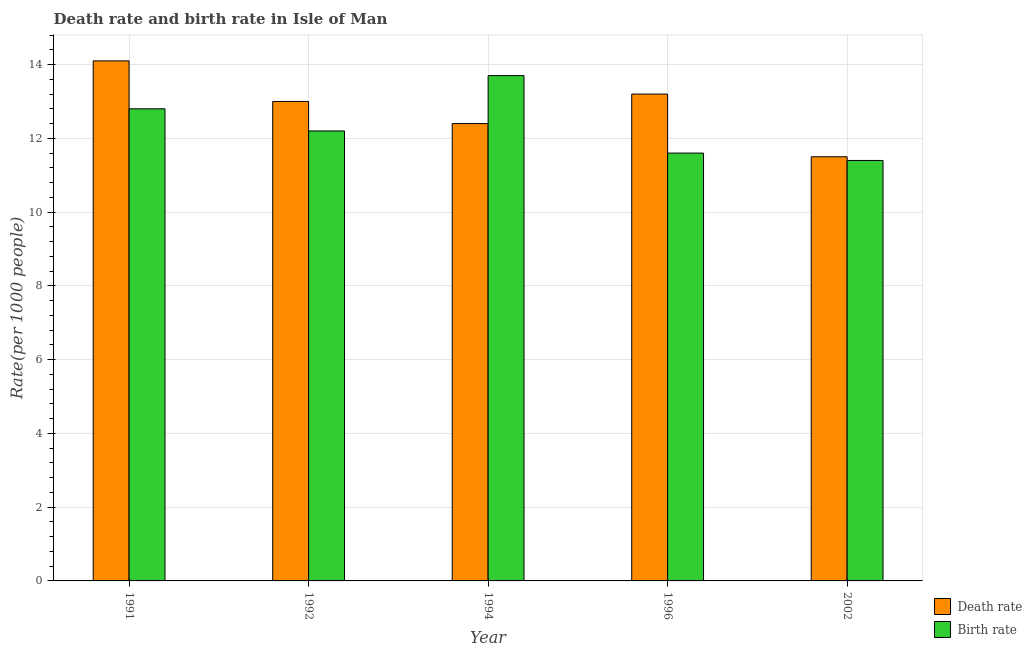How many different coloured bars are there?
Give a very brief answer. 2. How many groups of bars are there?
Your answer should be compact. 5. Are the number of bars per tick equal to the number of legend labels?
Your answer should be compact. Yes. How many bars are there on the 5th tick from the left?
Your response must be concise. 2. How many bars are there on the 3rd tick from the right?
Ensure brevity in your answer.  2. What is the label of the 5th group of bars from the left?
Keep it short and to the point. 2002. What is the death rate in 1992?
Ensure brevity in your answer.  13. In which year was the death rate maximum?
Provide a succinct answer. 1991. In which year was the birth rate minimum?
Your answer should be compact. 2002. What is the total birth rate in the graph?
Keep it short and to the point. 61.7. What is the difference between the death rate in 1994 and that in 1996?
Provide a succinct answer. -0.8. What is the difference between the death rate in 1992 and the birth rate in 1994?
Provide a succinct answer. 0.6. What is the average death rate per year?
Your answer should be very brief. 12.84. In the year 1994, what is the difference between the birth rate and death rate?
Offer a terse response. 0. In how many years, is the death rate greater than 4?
Your answer should be compact. 5. What is the ratio of the death rate in 1992 to that in 1996?
Make the answer very short. 0.98. What is the difference between the highest and the second highest death rate?
Your answer should be compact. 0.9. What is the difference between the highest and the lowest birth rate?
Keep it short and to the point. 2.3. In how many years, is the death rate greater than the average death rate taken over all years?
Offer a very short reply. 3. Is the sum of the birth rate in 1994 and 1996 greater than the maximum death rate across all years?
Your response must be concise. Yes. What does the 2nd bar from the left in 1991 represents?
Your response must be concise. Birth rate. What does the 1st bar from the right in 1994 represents?
Offer a very short reply. Birth rate. How many years are there in the graph?
Keep it short and to the point. 5. Does the graph contain grids?
Ensure brevity in your answer.  Yes. How many legend labels are there?
Offer a terse response. 2. What is the title of the graph?
Make the answer very short. Death rate and birth rate in Isle of Man. Does "Fertility rate" appear as one of the legend labels in the graph?
Keep it short and to the point. No. What is the label or title of the Y-axis?
Provide a succinct answer. Rate(per 1000 people). What is the Rate(per 1000 people) in Birth rate in 1992?
Your answer should be very brief. 12.2. What is the Rate(per 1000 people) in Birth rate in 1994?
Make the answer very short. 13.7. What is the Rate(per 1000 people) of Death rate in 1996?
Your answer should be very brief. 13.2. What is the Rate(per 1000 people) of Birth rate in 1996?
Offer a terse response. 11.6. What is the Rate(per 1000 people) of Birth rate in 2002?
Your answer should be very brief. 11.4. Across all years, what is the maximum Rate(per 1000 people) in Death rate?
Keep it short and to the point. 14.1. Across all years, what is the minimum Rate(per 1000 people) in Death rate?
Offer a terse response. 11.5. What is the total Rate(per 1000 people) of Death rate in the graph?
Ensure brevity in your answer.  64.2. What is the total Rate(per 1000 people) in Birth rate in the graph?
Keep it short and to the point. 61.7. What is the difference between the Rate(per 1000 people) of Death rate in 1991 and that in 1994?
Your response must be concise. 1.7. What is the difference between the Rate(per 1000 people) of Birth rate in 1991 and that in 1994?
Your answer should be very brief. -0.9. What is the difference between the Rate(per 1000 people) in Death rate in 1991 and that in 1996?
Offer a very short reply. 0.9. What is the difference between the Rate(per 1000 people) of Death rate in 1992 and that in 1994?
Your answer should be compact. 0.6. What is the difference between the Rate(per 1000 people) of Birth rate in 1992 and that in 1994?
Provide a succinct answer. -1.5. What is the difference between the Rate(per 1000 people) in Death rate in 1992 and that in 1996?
Provide a short and direct response. -0.2. What is the difference between the Rate(per 1000 people) of Death rate in 1992 and that in 2002?
Ensure brevity in your answer.  1.5. What is the difference between the Rate(per 1000 people) in Birth rate in 1994 and that in 2002?
Keep it short and to the point. 2.3. What is the difference between the Rate(per 1000 people) of Death rate in 1996 and that in 2002?
Provide a succinct answer. 1.7. What is the difference between the Rate(per 1000 people) in Birth rate in 1996 and that in 2002?
Keep it short and to the point. 0.2. What is the difference between the Rate(per 1000 people) in Death rate in 1991 and the Rate(per 1000 people) in Birth rate in 1992?
Provide a short and direct response. 1.9. What is the difference between the Rate(per 1000 people) of Death rate in 1991 and the Rate(per 1000 people) of Birth rate in 1996?
Give a very brief answer. 2.5. What is the difference between the Rate(per 1000 people) in Death rate in 1991 and the Rate(per 1000 people) in Birth rate in 2002?
Make the answer very short. 2.7. What is the difference between the Rate(per 1000 people) of Death rate in 1992 and the Rate(per 1000 people) of Birth rate in 1994?
Make the answer very short. -0.7. What is the difference between the Rate(per 1000 people) in Death rate in 1992 and the Rate(per 1000 people) in Birth rate in 1996?
Provide a succinct answer. 1.4. What is the difference between the Rate(per 1000 people) in Death rate in 1992 and the Rate(per 1000 people) in Birth rate in 2002?
Your answer should be compact. 1.6. What is the difference between the Rate(per 1000 people) in Death rate in 1994 and the Rate(per 1000 people) in Birth rate in 2002?
Your answer should be compact. 1. What is the difference between the Rate(per 1000 people) in Death rate in 1996 and the Rate(per 1000 people) in Birth rate in 2002?
Keep it short and to the point. 1.8. What is the average Rate(per 1000 people) in Death rate per year?
Keep it short and to the point. 12.84. What is the average Rate(per 1000 people) in Birth rate per year?
Your response must be concise. 12.34. In the year 1991, what is the difference between the Rate(per 1000 people) of Death rate and Rate(per 1000 people) of Birth rate?
Your answer should be very brief. 1.3. In the year 1992, what is the difference between the Rate(per 1000 people) in Death rate and Rate(per 1000 people) in Birth rate?
Your response must be concise. 0.8. In the year 2002, what is the difference between the Rate(per 1000 people) of Death rate and Rate(per 1000 people) of Birth rate?
Give a very brief answer. 0.1. What is the ratio of the Rate(per 1000 people) in Death rate in 1991 to that in 1992?
Your answer should be compact. 1.08. What is the ratio of the Rate(per 1000 people) in Birth rate in 1991 to that in 1992?
Make the answer very short. 1.05. What is the ratio of the Rate(per 1000 people) of Death rate in 1991 to that in 1994?
Your response must be concise. 1.14. What is the ratio of the Rate(per 1000 people) of Birth rate in 1991 to that in 1994?
Offer a terse response. 0.93. What is the ratio of the Rate(per 1000 people) in Death rate in 1991 to that in 1996?
Give a very brief answer. 1.07. What is the ratio of the Rate(per 1000 people) of Birth rate in 1991 to that in 1996?
Your answer should be very brief. 1.1. What is the ratio of the Rate(per 1000 people) of Death rate in 1991 to that in 2002?
Keep it short and to the point. 1.23. What is the ratio of the Rate(per 1000 people) of Birth rate in 1991 to that in 2002?
Offer a very short reply. 1.12. What is the ratio of the Rate(per 1000 people) in Death rate in 1992 to that in 1994?
Make the answer very short. 1.05. What is the ratio of the Rate(per 1000 people) in Birth rate in 1992 to that in 1994?
Your answer should be very brief. 0.89. What is the ratio of the Rate(per 1000 people) in Death rate in 1992 to that in 1996?
Provide a succinct answer. 0.98. What is the ratio of the Rate(per 1000 people) of Birth rate in 1992 to that in 1996?
Make the answer very short. 1.05. What is the ratio of the Rate(per 1000 people) of Death rate in 1992 to that in 2002?
Give a very brief answer. 1.13. What is the ratio of the Rate(per 1000 people) of Birth rate in 1992 to that in 2002?
Your response must be concise. 1.07. What is the ratio of the Rate(per 1000 people) of Death rate in 1994 to that in 1996?
Your answer should be very brief. 0.94. What is the ratio of the Rate(per 1000 people) of Birth rate in 1994 to that in 1996?
Offer a very short reply. 1.18. What is the ratio of the Rate(per 1000 people) of Death rate in 1994 to that in 2002?
Your answer should be very brief. 1.08. What is the ratio of the Rate(per 1000 people) of Birth rate in 1994 to that in 2002?
Your answer should be very brief. 1.2. What is the ratio of the Rate(per 1000 people) of Death rate in 1996 to that in 2002?
Your answer should be very brief. 1.15. What is the ratio of the Rate(per 1000 people) in Birth rate in 1996 to that in 2002?
Your answer should be compact. 1.02. What is the difference between the highest and the second highest Rate(per 1000 people) of Birth rate?
Your response must be concise. 0.9. What is the difference between the highest and the lowest Rate(per 1000 people) of Death rate?
Offer a terse response. 2.6. What is the difference between the highest and the lowest Rate(per 1000 people) in Birth rate?
Provide a succinct answer. 2.3. 